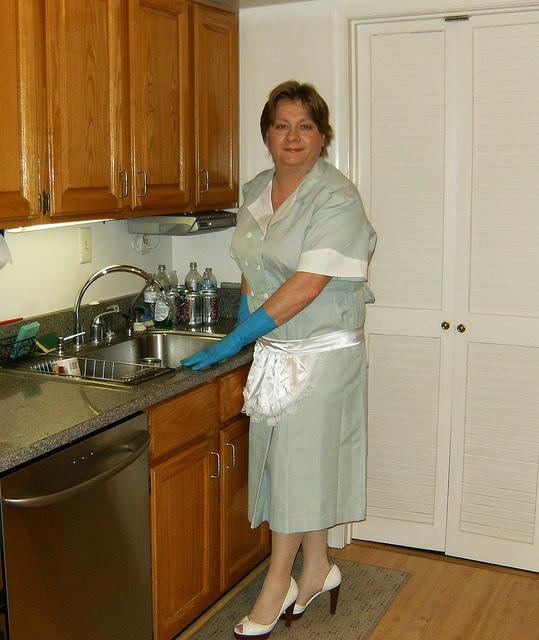Where may this lady be completing the cleaning?

Choices:
A) hotel
B) nursing home
C) residence
D) conference center residence 